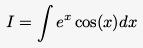Convert formula to latex. <formula><loc_0><loc_0><loc_500><loc_500>I = \int e ^ { x } \cos ( x ) d x</formula> 